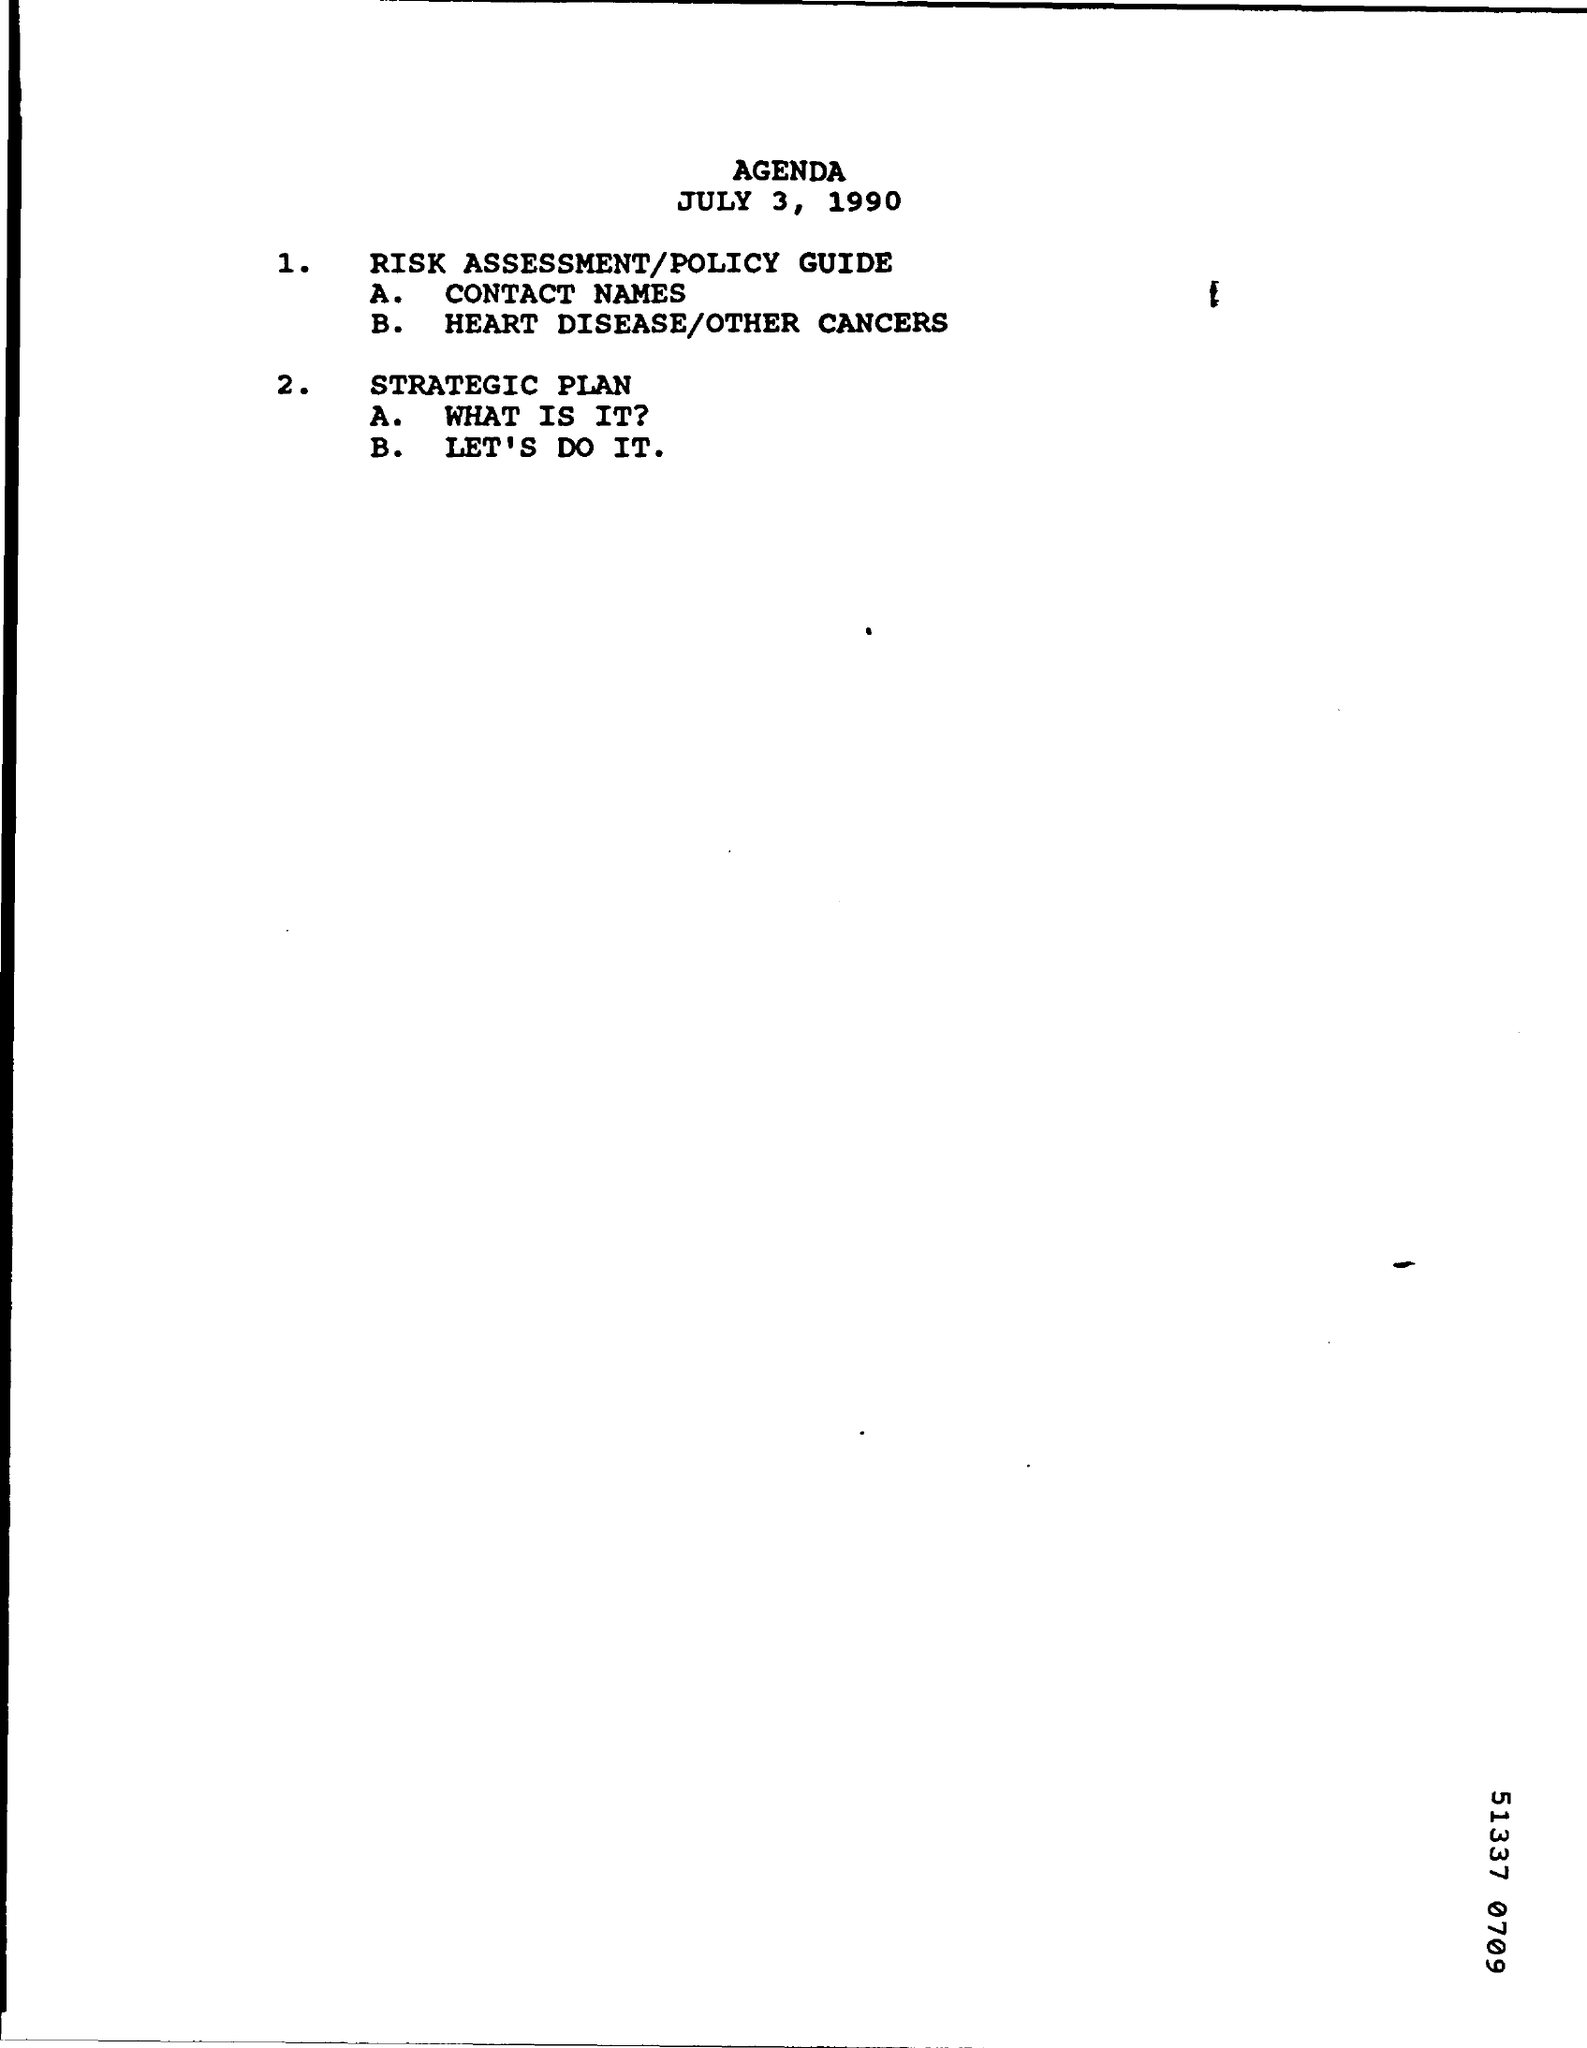What is the Title of the document?
Provide a succinct answer. AGENDA. 